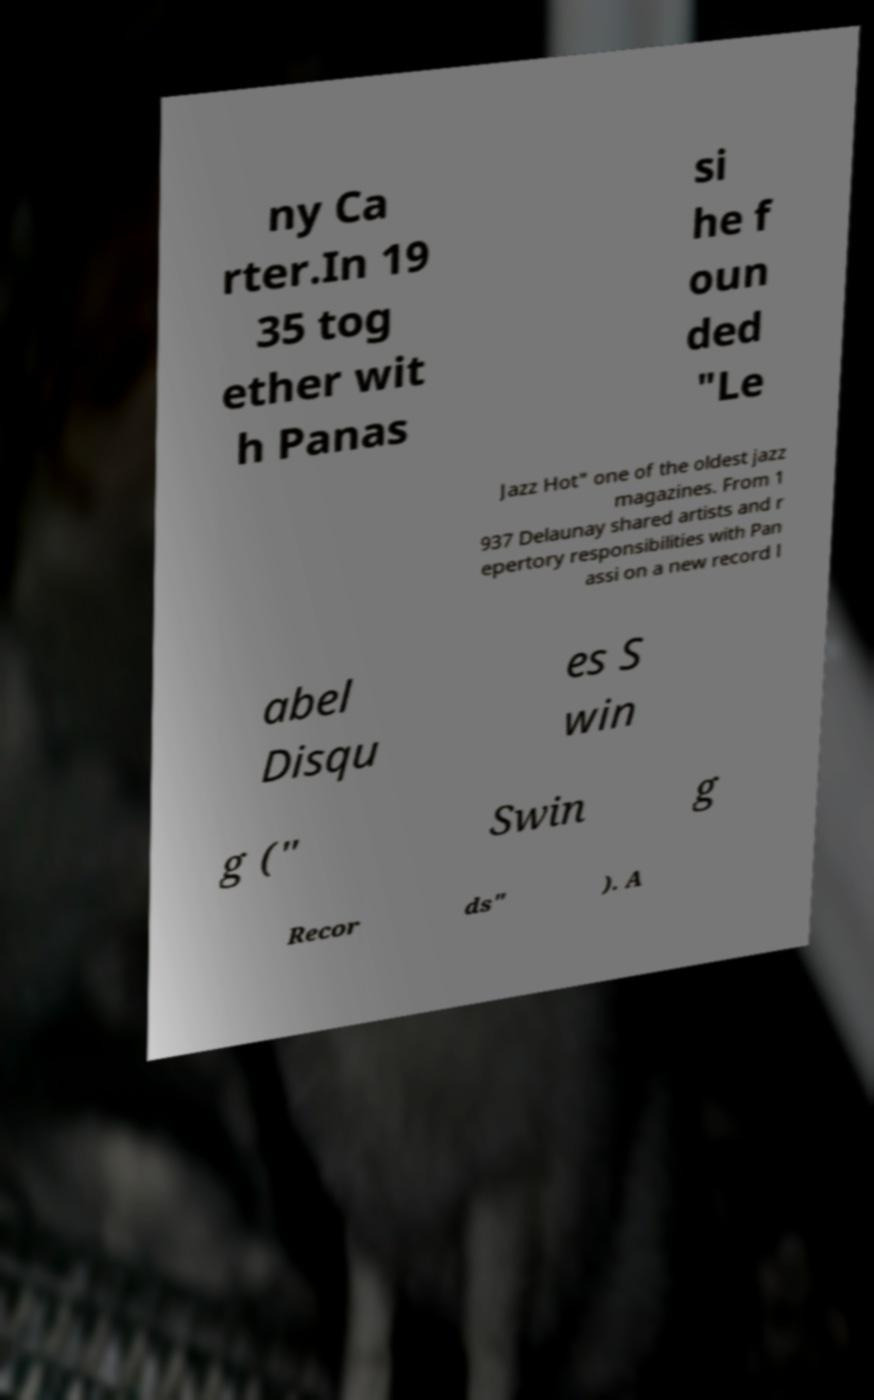Could you extract and type out the text from this image? ny Ca rter.In 19 35 tog ether wit h Panas si he f oun ded "Le Jazz Hot" one of the oldest jazz magazines. From 1 937 Delaunay shared artists and r epertory responsibilities with Pan assi on a new record l abel Disqu es S win g (" Swin g Recor ds" ). A 